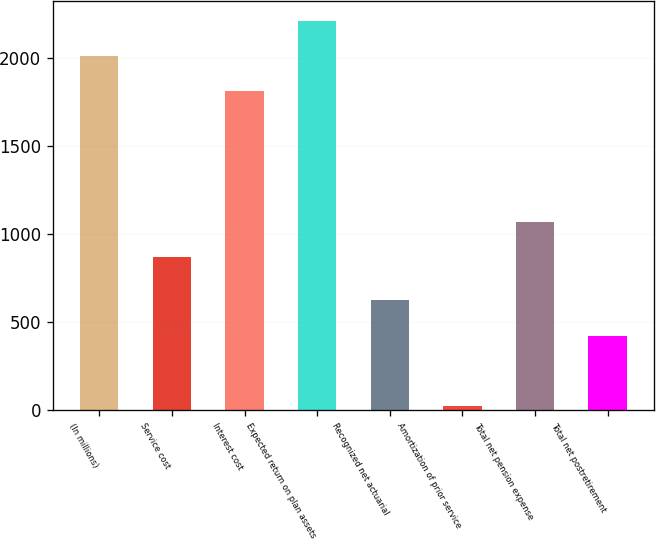Convert chart to OTSL. <chart><loc_0><loc_0><loc_500><loc_500><bar_chart><fcel>(In millions)<fcel>Service cost<fcel>Interest cost<fcel>Expected return on plan assets<fcel>Recognized net actuarial<fcel>Amortization of prior service<fcel>Total net pension expense<fcel>Total net postretirement<nl><fcel>2012.5<fcel>870<fcel>1812<fcel>2213<fcel>624.5<fcel>23<fcel>1070.5<fcel>424<nl></chart> 